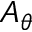<formula> <loc_0><loc_0><loc_500><loc_500>A _ { \theta }</formula> 